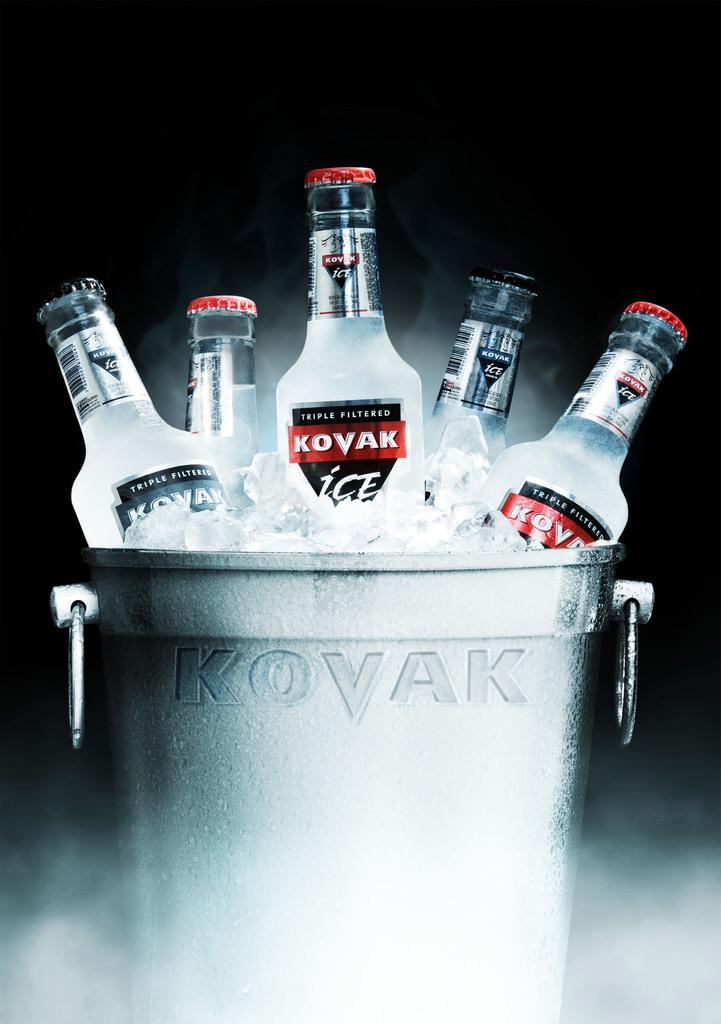What is the main subject of the image? The main subject of the image is a group of bottles. What can be observed about the bottles in the image? The bottles have labels and lids. How are the bottles arranged in the image? The bottles are placed in a bucket of ice cubes. What can be inferred about the background of the image? The background of the image is dark. What type of skin condition can be seen on the bottles in the image? There is no skin condition present on the bottles in the image; they are inanimate objects. Can you tell me how many airports are visible in the image? There are no airports present in the image; it features a group of bottles in a bucket of ice cubes. 